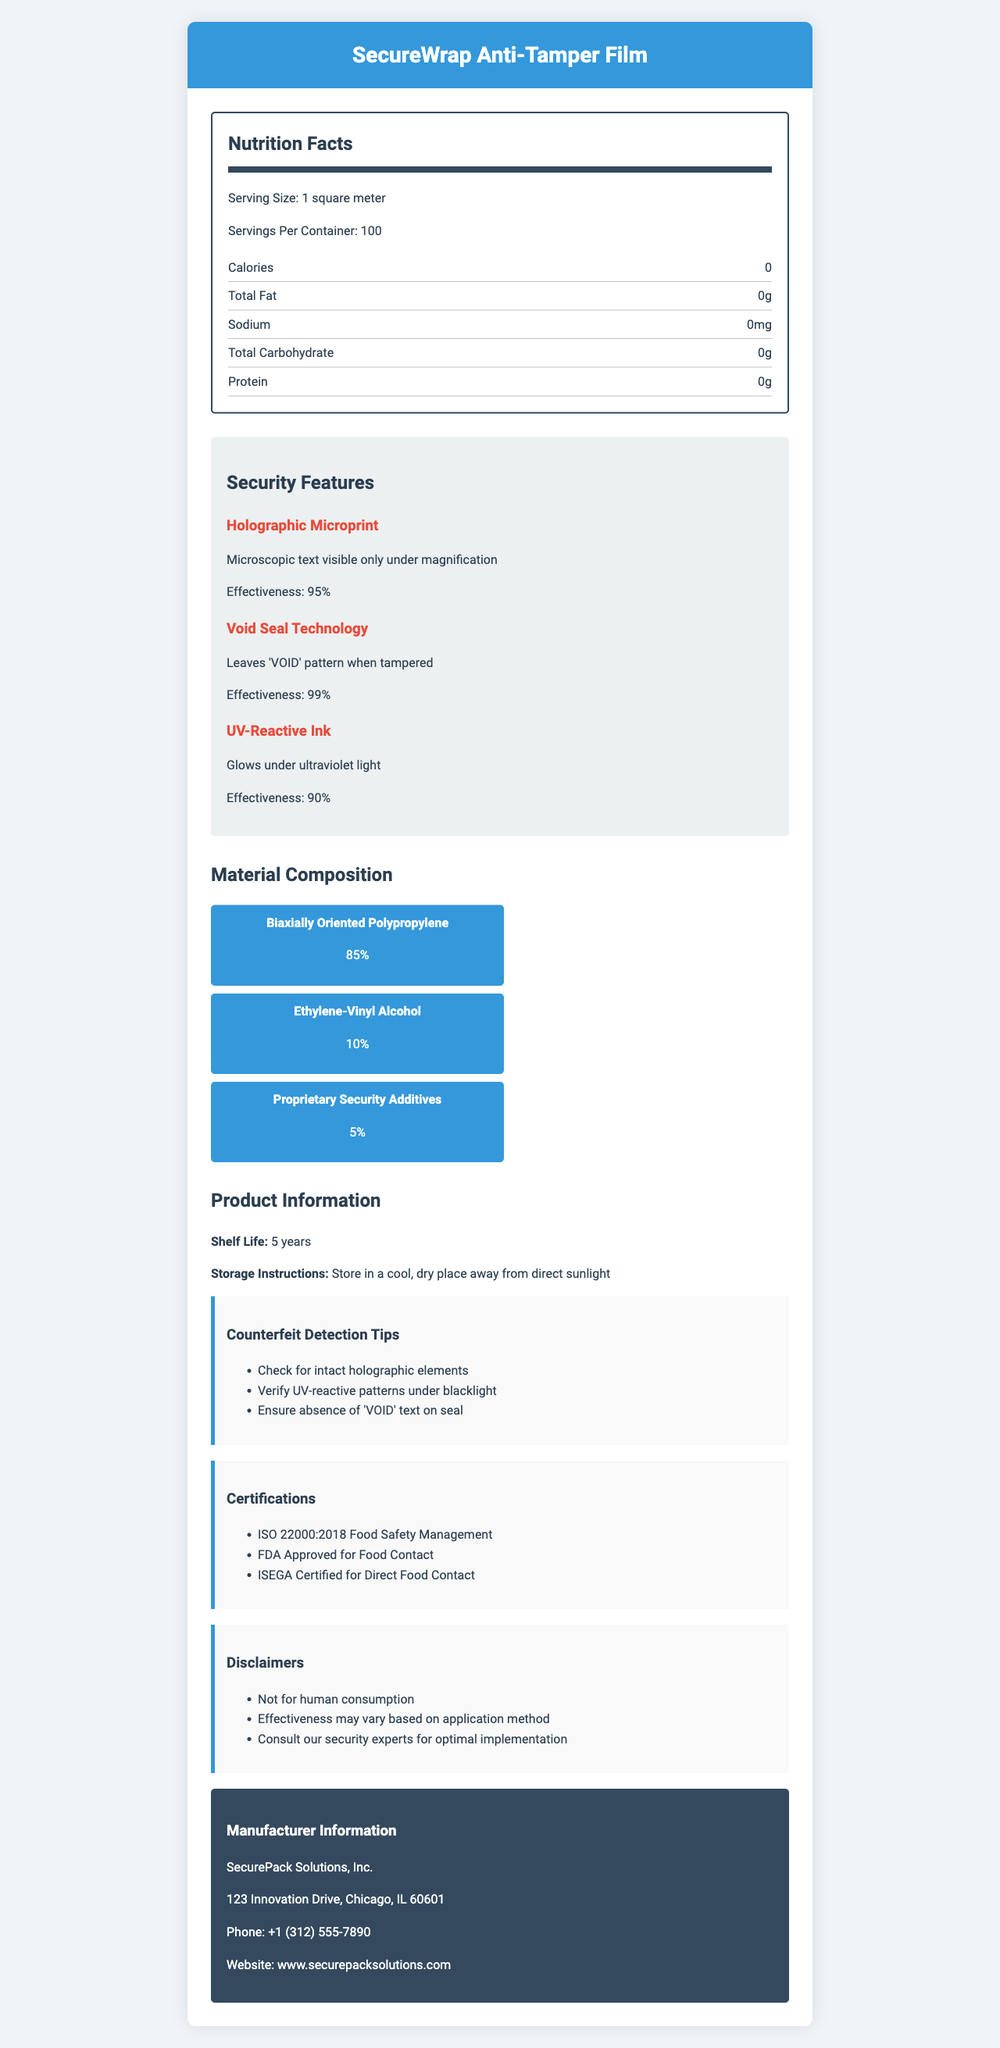what is the serving size for SecureWrap Anti-Tamper Film? The serving size is directly mentioned as 1 square meter under the Nutrition Facts section of the document.
Answer: 1 square meter how many calories does SecureWrap Anti-Tamper Film have? The Nutrition Facts section clearly states that the product has 0 calories.
Answer: 0 what does the Void Seal Technology do? The Security Features section describes Void Seal Technology as leaving a 'VOID' pattern when tampered.
Answer: Leaves 'VOID' pattern when tampered what is the shelf life of SecureWrap Anti-Tamper Film? The shelf life is specifically mentioned as 5 years under the Product Information section of the document.
Answer: 5 years who is the manufacturer of SecureWrap Anti-Tamper Film? The Manufacturer Information section lists SecurePack Solutions, Inc. as the manufacturer.
Answer: SecurePack Solutions, Inc. which of the following is a security feature of SecureWrap Anti-Tamper Film? A. Watermark B. Holographic Microprint C. Barcode D. QR Code The Security Features section lists Holographic Microprint as one of the security features.
Answer: B what percentage of the material composition is Biaxially Oriented Polypropylene? A. 85% B. 10% C. 5% D. 90% The Material Composition section states that Biaxially Oriented Polypropylene makes up 85% of the material composition.
Answer: A is SecureWrap Anti-Tamper Film approved for food contact by the FDA? One of the certifications listed is FDA Approved for Food Contact.
Answer: Yes summarize the main idea of the document. The document details the SecureWrap Anti-Tamper Film including its nutrition facts, security features, material composition, certifications, manufacturer information, and counterfeit detection tips.
Answer: SecureWrap Anti-Tamper Film is a tamper-evident packaging material that includes multiple security features such as Holographic Microprint, Void Seal Technology, and UV-Reactive Ink. The film is composed primarily of Biaxially Oriented Polypropylene and is certified safe for food contact, with a shelf life of 5 years. Manufactured by SecurePack Solutions, Inc., guidelines for detection and storage are also provided. what are the instructions for storage of SecureWrap Anti-Tamper Film? The storage instructions are given under the Product Information section, and they advise storing the product in a cool, dry place away from direct sunlight.
Answer: Store in a cool, dry place away from direct sunlight what effectiveness rating does the UV-Reactive Ink have? The Security Features section lists UV-Reactive Ink with an effectiveness rating of 90%.
Answer: 90% what should you check for to detect counterfeit SecureWrap Anti-Tamper Film? The Counterfeit Detection Tips section includes these specific recommendations to detect counterfeit products.
Answer: Check for intact holographic elements, verify UV-reactive patterns under blacklight, ensure the absence of the 'VOID' text on seal how many years is the shelf life of SecureWrap Anti-Tamper Film? The Product Information section explicitly states that the shelf life is 5 years.
Answer: 5 years can SecureWrap Anti-Tamper Film be consumed by humans? One of the disclaimers mentions that the product is not for human consumption.
Answer: No what is the phone number for SecurePack Solutions, Inc.? The Manufacturer Information section provides the phone number as +1 (312) 555-7890.
Answer: +1 (312) 555-7890 how effective is the Void Seal Technology? The Security Features section rates the effectiveness of Void Seal Technology at 99%.
Answer: 99% does SecureWrap Anti-Tamper Film contain any protein? The Nutrition Facts section indicates that the product contains 0g of protein.
Answer: No how many security features are listed for SecureWrap Anti-Tamper Film? The Security Features section lists three features: Holographic Microprint, Void Seal Technology, and UV-Reactive Ink.
Answer: Three (3) what is the main address for SecurePack Solutions, Inc.? The Manufacturer Information section provides the address as 123 Innovation Drive, Chicago, IL 60601.
Answer: 123 Innovation Drive, Chicago, IL 60601 what is the percentage composition of Ethylene-Vinyl Alcohol in the SecureWrap Anti-Tamper Film? The Material Composition section lists Ethylene-Vinyl Alcohol as making up 10% of the material.
Answer: 10% 